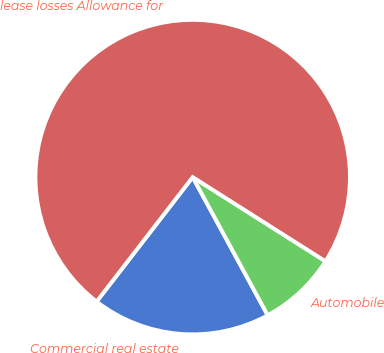Convert chart. <chart><loc_0><loc_0><loc_500><loc_500><pie_chart><fcel>Commercial real estate<fcel>Automobile<fcel>lease losses Allowance for<nl><fcel>18.38%<fcel>8.09%<fcel>73.53%<nl></chart> 